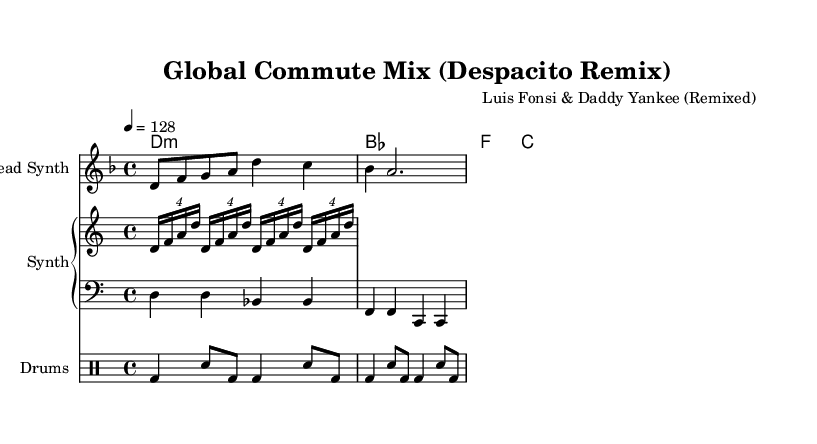What is the key signature of this music? The key signature is indicated at the beginning of the staff. It shows two flats (B♭ and E♭), which signifies D minor.
Answer: D minor What is the time signature of this music? The time signature is shown next to the key signature. It is notated as a fraction that indicates 4 beats per measure, commonly described as 4/4.
Answer: 4/4 What is the tempo marking for this piece? The tempo is shown above the music staff, written as a metronome marking (4 = 128), which indicates that there are 128 quarter-note beats per minute.
Answer: 128 How many measures does the melody section consist of? Counting the line segments in the melody, there are four measures indicated by vertical bar lines.
Answer: 4 What instrument plays the arpeggiator part? The arpeggiator is indicated within the PianoStaff section. It is played in the lower staff, which typically corresponds to a synth or keyboard instrument.
Answer: Synth Describe the drum pattern's starting note. The drum pattern starts with a bass drum (bd), which is the first note in the pattern. This can be identified as the notation notating the bass drum sound in the drummode section.
Answer: Bass drum What type of music genre does this piece represent? The arrangement and components like synthesizers and electronic elements in the piece indicate that it's part of electronic pop music, often characterized by upbeat and energetic remixes.
Answer: Electronic pop 